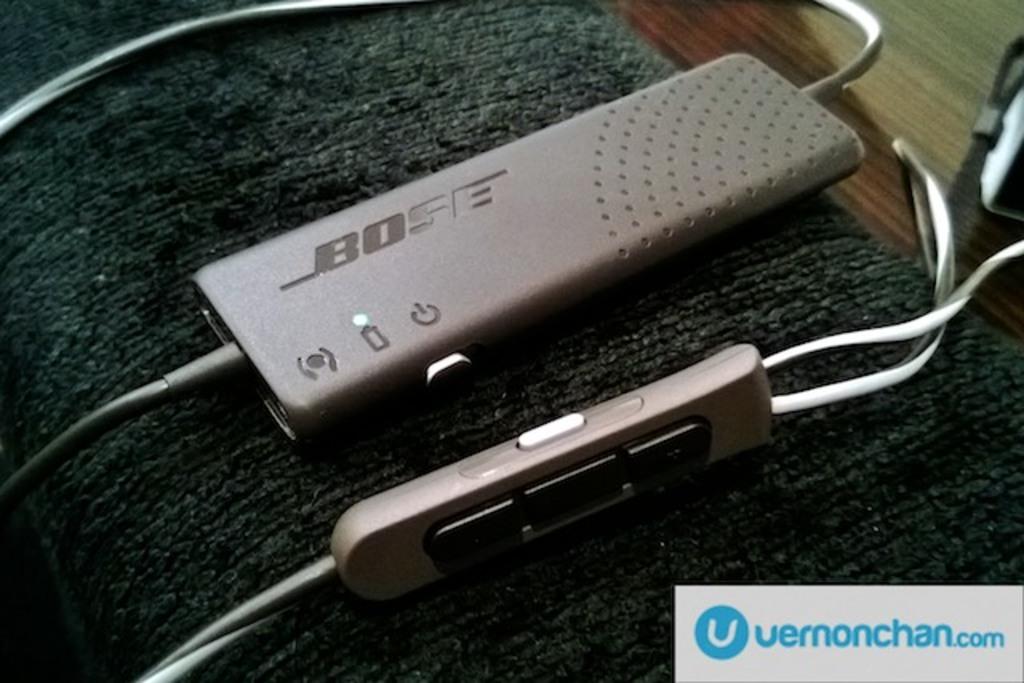What brand is this electronic equipment?
Give a very brief answer. Bose. This brand is power bank in electronic equipment?
Offer a very short reply. Bose. 